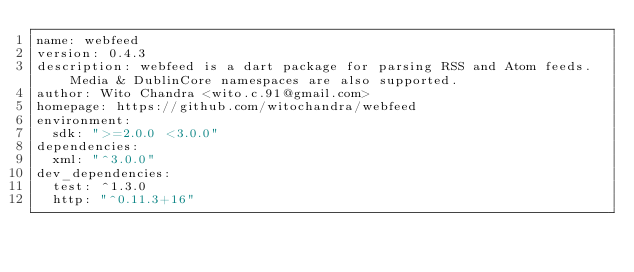<code> <loc_0><loc_0><loc_500><loc_500><_YAML_>name: webfeed
version: 0.4.3
description: webfeed is a dart package for parsing RSS and Atom feeds. Media & DublinCore namespaces are also supported.
author: Wito Chandra <wito.c.91@gmail.com>
homepage: https://github.com/witochandra/webfeed
environment:
  sdk: ">=2.0.0 <3.0.0"
dependencies:
  xml: "^3.0.0"
dev_dependencies:
  test: ^1.3.0
  http: "^0.11.3+16"
</code> 